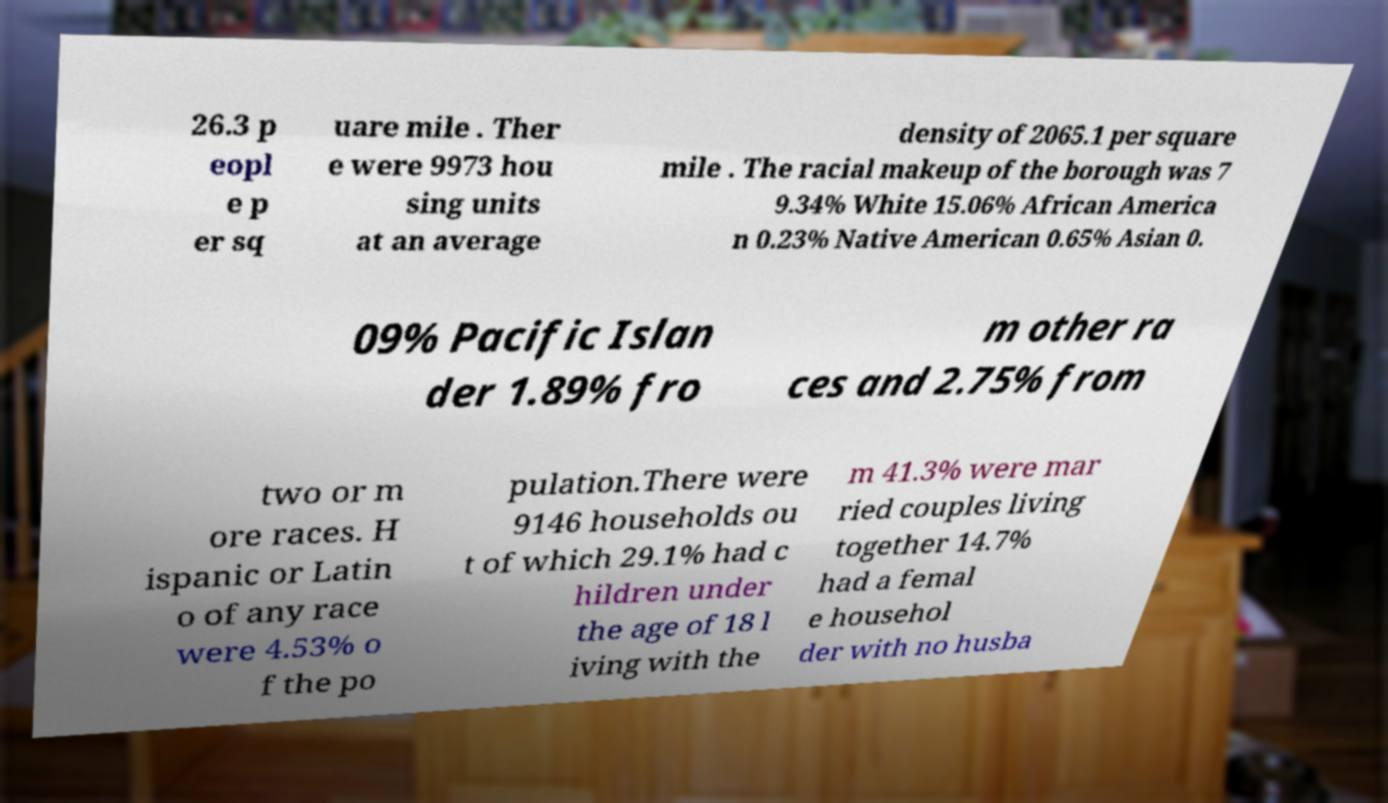For documentation purposes, I need the text within this image transcribed. Could you provide that? 26.3 p eopl e p er sq uare mile . Ther e were 9973 hou sing units at an average density of 2065.1 per square mile . The racial makeup of the borough was 7 9.34% White 15.06% African America n 0.23% Native American 0.65% Asian 0. 09% Pacific Islan der 1.89% fro m other ra ces and 2.75% from two or m ore races. H ispanic or Latin o of any race were 4.53% o f the po pulation.There were 9146 households ou t of which 29.1% had c hildren under the age of 18 l iving with the m 41.3% were mar ried couples living together 14.7% had a femal e househol der with no husba 